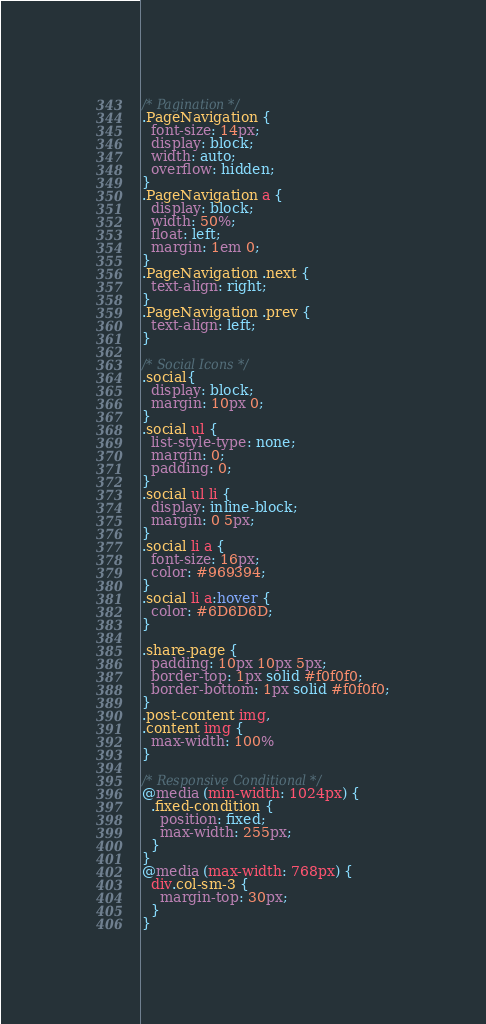Convert code to text. <code><loc_0><loc_0><loc_500><loc_500><_CSS_>
/* Pagination */
.PageNavigation {
  font-size: 14px;
  display: block;
  width: auto;
  overflow: hidden;
}
.PageNavigation a {
  display: block;
  width: 50%;
  float: left;
  margin: 1em 0;
}
.PageNavigation .next {
  text-align: right;
}
.PageNavigation .prev {
  text-align: left;
}

/* Social Icons */
.social{
  display: block;
  margin: 10px 0;
}
.social ul {
  list-style-type: none;
  margin: 0;
  padding: 0;
}
.social ul li {
  display: inline-block;
  margin: 0 5px;
}
.social li a {
  font-size: 16px;
  color: #969394;
}
.social li a:hover {
  color: #6D6D6D;
}

.share-page {
  padding: 10px 10px 5px;
  border-top: 1px solid #f0f0f0;
  border-bottom: 1px solid #f0f0f0;
}
.post-content img,
.content img {
  max-width: 100%
}

/* Responsive Conditional */
@media (min-width: 1024px) {
  .fixed-condition {
    position: fixed;
    max-width: 255px;
  }
}
@media (max-width: 768px) {
  div.col-sm-3 {
    margin-top: 30px;
  }
}
</code> 